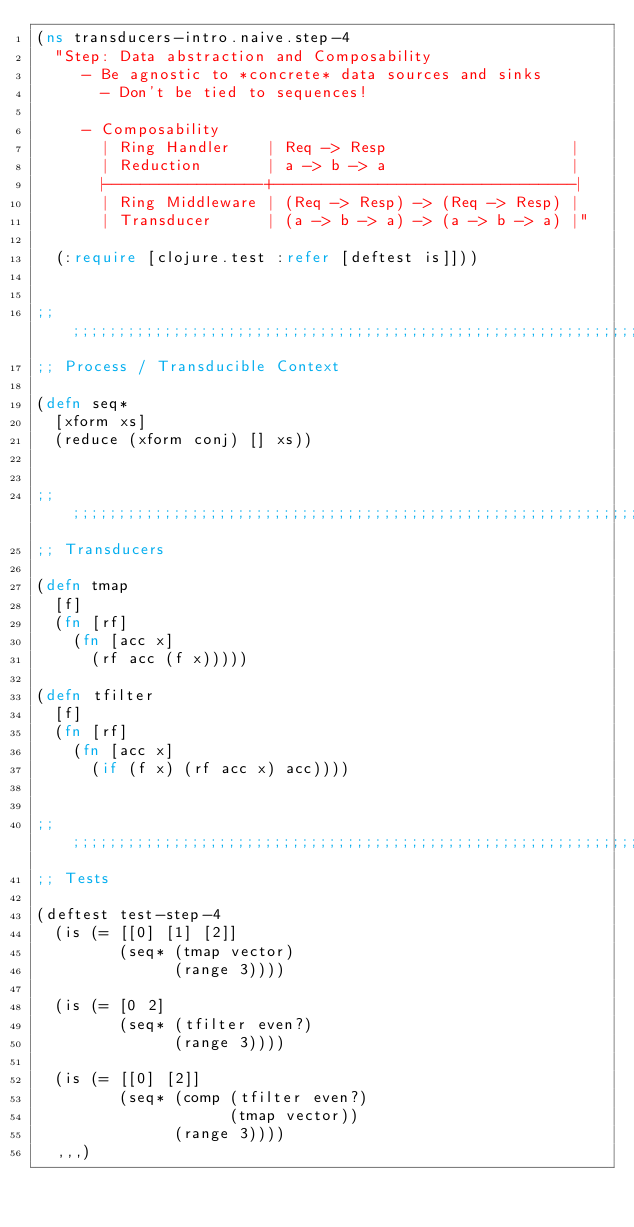Convert code to text. <code><loc_0><loc_0><loc_500><loc_500><_Clojure_>(ns transducers-intro.naive.step-4
  "Step: Data abstraction and Composability
     - Be agnostic to *concrete* data sources and sinks
       - Don't be tied to sequences!

     - Composability
       | Ring Handler    | Req -> Resp                    |
       | Reduction       | a -> b -> a                    |
       |-----------------+--------------------------------|
       | Ring Middleware | (Req -> Resp) -> (Req -> Resp) |
       | Transducer      | (a -> b -> a) -> (a -> b -> a) |"

  (:require [clojure.test :refer [deftest is]]))


;; ;;;;;;;;;;;;;;;;;;;;;;;;;;;;;;;;;;;;;;;;;;;;;;;;;;;;;;;;;;;;;;;;;;;;;;;;;;;;;
;; Process / Transducible Context

(defn seq*
  [xform xs]
  (reduce (xform conj) [] xs))


;; ;;;;;;;;;;;;;;;;;;;;;;;;;;;;;;;;;;;;;;;;;;;;;;;;;;;;;;;;;;;;;;;;;;;;;;;;;;;;;
;; Transducers

(defn tmap
  [f]
  (fn [rf]
    (fn [acc x]
      (rf acc (f x)))))

(defn tfilter
  [f]
  (fn [rf]
    (fn [acc x]
      (if (f x) (rf acc x) acc))))


;; ;;;;;;;;;;;;;;;;;;;;;;;;;;;;;;;;;;;;;;;;;;;;;;;;;;;;;;;;;;;;;;;;;;;;;;;;;;;;;
;; Tests

(deftest test-step-4
  (is (= [[0] [1] [2]]
         (seq* (tmap vector)
               (range 3))))

  (is (= [0 2]
         (seq* (tfilter even?)
               (range 3))))

  (is (= [[0] [2]]
         (seq* (comp (tfilter even?)
                     (tmap vector))
               (range 3))))
  ,,,)
</code> 